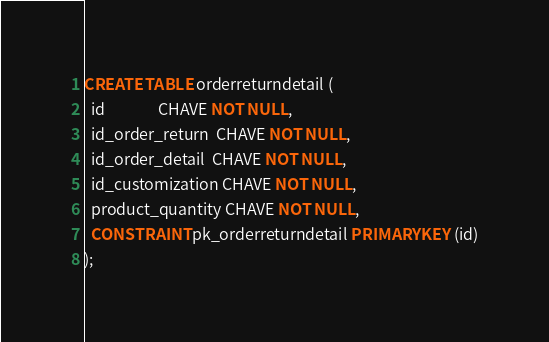Convert code to text. <code><loc_0><loc_0><loc_500><loc_500><_SQL_>CREATE TABLE orderreturndetail (
  id               CHAVE NOT NULL,
  id_order_return  CHAVE NOT NULL,
  id_order_detail  CHAVE NOT NULL,
  id_customization CHAVE NOT NULL,
  product_quantity CHAVE NOT NULL,
  CONSTRAINT pk_orderreturndetail PRIMARY KEY (id)
);</code> 